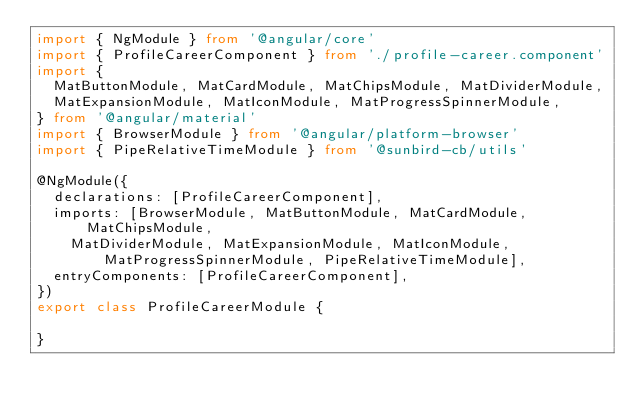<code> <loc_0><loc_0><loc_500><loc_500><_TypeScript_>import { NgModule } from '@angular/core'
import { ProfileCareerComponent } from './profile-career.component'
import {
  MatButtonModule, MatCardModule, MatChipsModule, MatDividerModule,
  MatExpansionModule, MatIconModule, MatProgressSpinnerModule,
} from '@angular/material'
import { BrowserModule } from '@angular/platform-browser'
import { PipeRelativeTimeModule } from '@sunbird-cb/utils'

@NgModule({
  declarations: [ProfileCareerComponent],
  imports: [BrowserModule, MatButtonModule, MatCardModule, MatChipsModule,
    MatDividerModule, MatExpansionModule, MatIconModule, MatProgressSpinnerModule, PipeRelativeTimeModule],
  entryComponents: [ProfileCareerComponent],
})
export class ProfileCareerModule {

}
</code> 